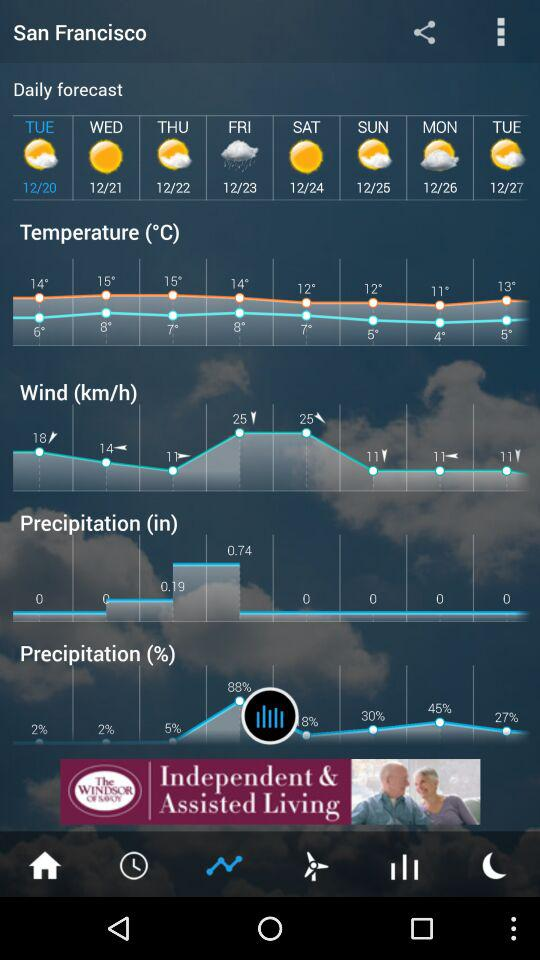What is the current location? The current location is San Francisco. 